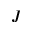<formula> <loc_0><loc_0><loc_500><loc_500>J</formula> 